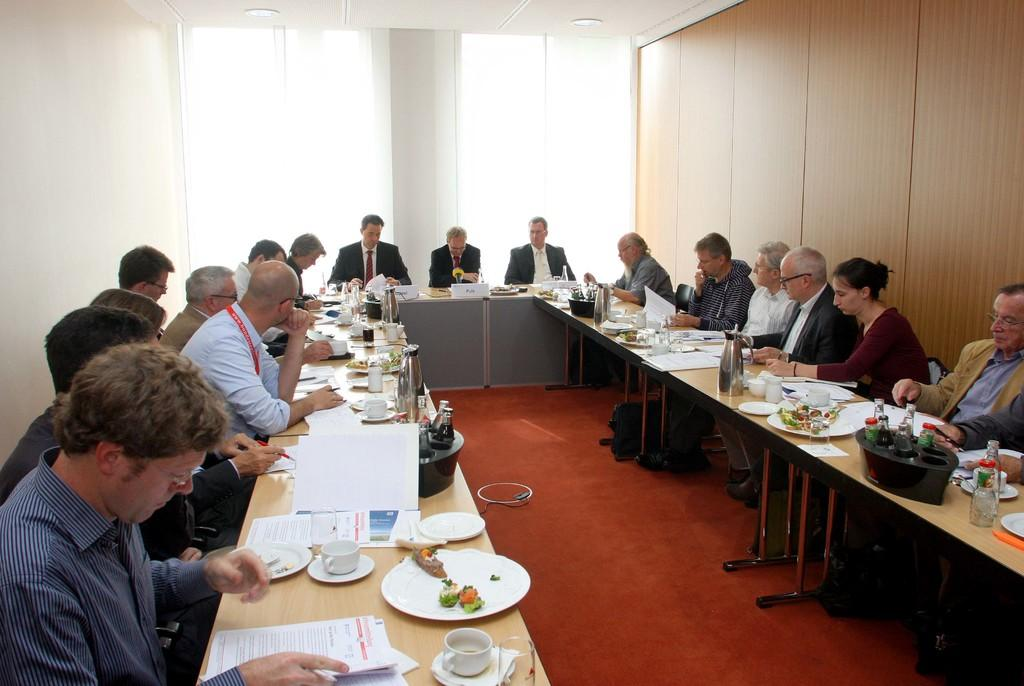What are the people in the image doing? There is a group of people sitting on chairs in the image. What is on the table in the image? There is a cup, a saucer, a plate, food, papers, and a bottle on the table in the image. Can you describe the table setting in the image? The table setting includes a cup, a saucer, a plate, food, and papers. What might be used for holding a beverage in the image? The cup on the table might be used for holding a beverage. What type of pump can be seen in the image? There is no pump present in the image. How many beetles are crawling on the table in the image? There are no beetles present in the image. 